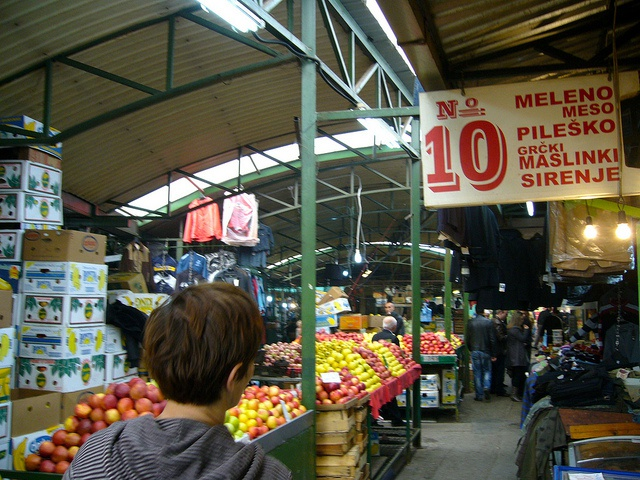Describe the objects in this image and their specific colors. I can see people in black, gray, maroon, and olive tones, apple in black, maroon, and brown tones, apple in black, salmon, tan, and khaki tones, people in black, navy, and blue tones, and people in black, darkgreen, and gray tones in this image. 